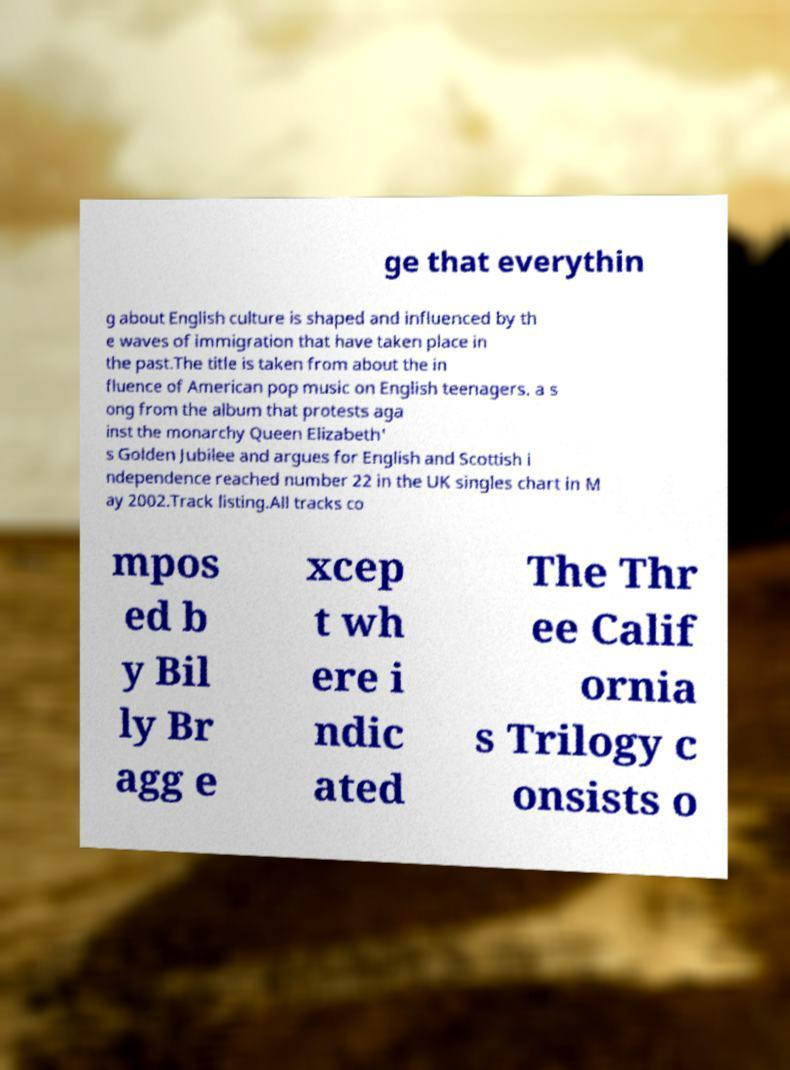Please identify and transcribe the text found in this image. ge that everythin g about English culture is shaped and influenced by th e waves of immigration that have taken place in the past.The title is taken from about the in fluence of American pop music on English teenagers. a s ong from the album that protests aga inst the monarchy Queen Elizabeth' s Golden Jubilee and argues for English and Scottish i ndependence reached number 22 in the UK singles chart in M ay 2002.Track listing.All tracks co mpos ed b y Bil ly Br agg e xcep t wh ere i ndic ated The Thr ee Calif ornia s Trilogy c onsists o 